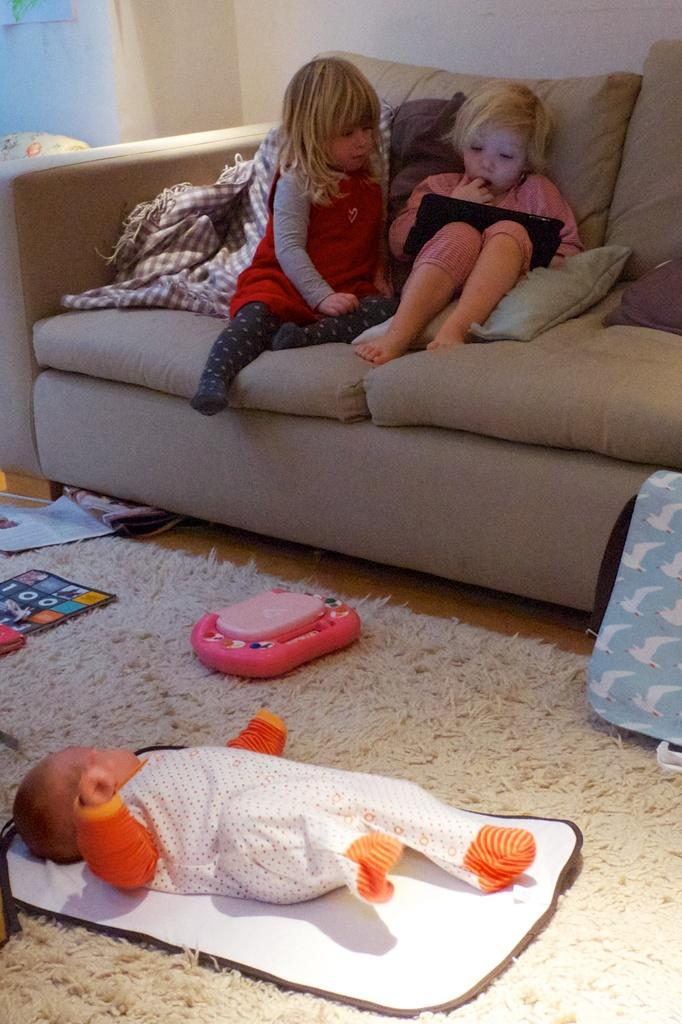How many children are in the image? There are two children in the image. What are the children doing in the image? The children are sitting on a couch. Is there anyone else besides the children in the image? Yes, there is a baby laying on the floor. What else can be seen in the image? Toys are present in the image. How many chains can be seen hanging from the ceiling in the image? There are no chains hanging from the ceiling in the image. 